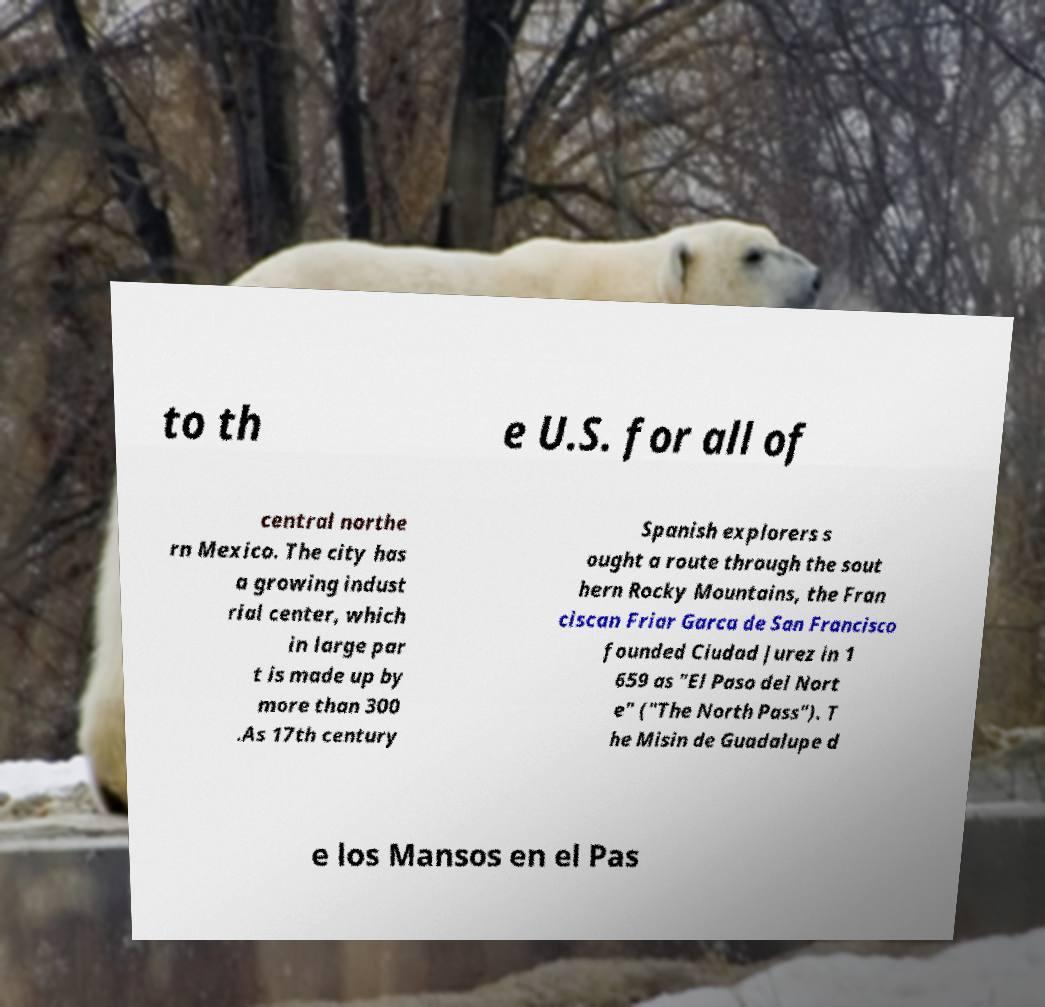Please identify and transcribe the text found in this image. to th e U.S. for all of central northe rn Mexico. The city has a growing indust rial center, which in large par t is made up by more than 300 .As 17th century Spanish explorers s ought a route through the sout hern Rocky Mountains, the Fran ciscan Friar Garca de San Francisco founded Ciudad Jurez in 1 659 as "El Paso del Nort e" ("The North Pass"). T he Misin de Guadalupe d e los Mansos en el Pas 